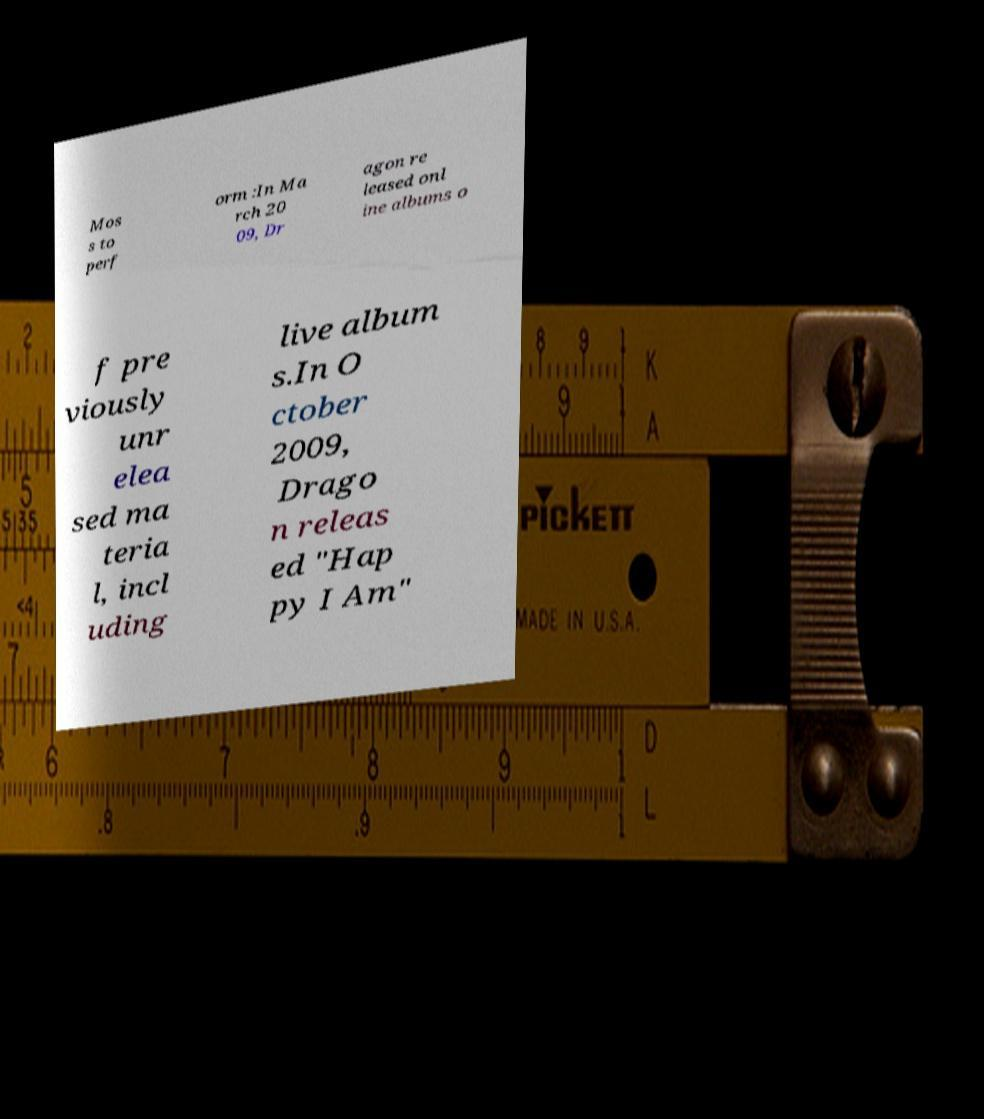Can you accurately transcribe the text from the provided image for me? Mos s to perf orm :In Ma rch 20 09, Dr agon re leased onl ine albums o f pre viously unr elea sed ma teria l, incl uding live album s.In O ctober 2009, Drago n releas ed "Hap py I Am" 